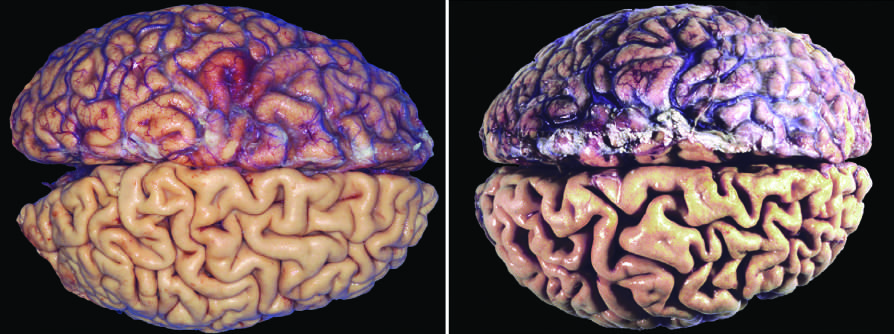have the meninges been stripped from the bottom half of each specimen to show the surface of the brain?
Answer the question using a single word or phrase. Yes 